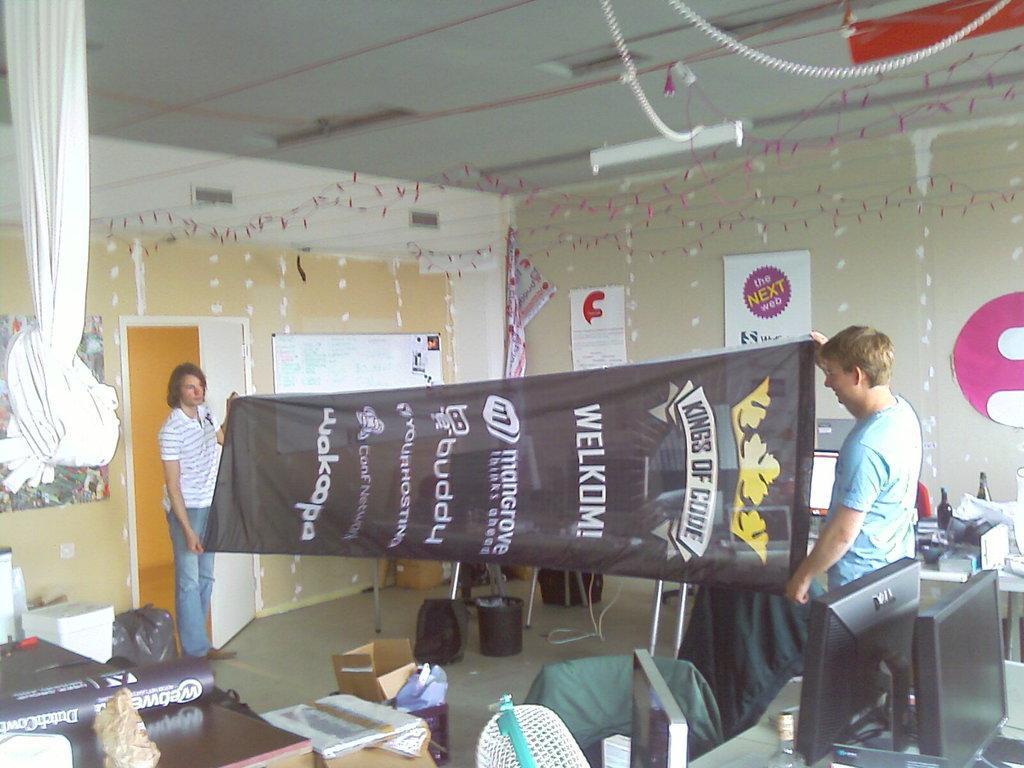Could you give a brief overview of what you see in this image? There are two people standing and holding a banner in their hands. I can see the cardboard boxes. This looks like a dustbin. This is a table with the three monitors and few other objects on it. These are the posters and a board, which are attached to the walls. This looks like a cloth, which is hanging. On the left side of the image, I can see few objects on it. I think these are the decorative items, which are hanging. This looks like a bag, which is on the floor. On the right side of the image, I can see another table with bottles and few other things on it. This is a door. 